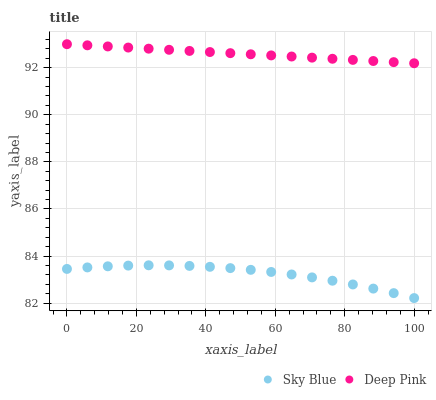Does Sky Blue have the minimum area under the curve?
Answer yes or no. Yes. Does Deep Pink have the maximum area under the curve?
Answer yes or no. Yes. Does Deep Pink have the minimum area under the curve?
Answer yes or no. No. Is Deep Pink the smoothest?
Answer yes or no. Yes. Is Sky Blue the roughest?
Answer yes or no. Yes. Is Deep Pink the roughest?
Answer yes or no. No. Does Sky Blue have the lowest value?
Answer yes or no. Yes. Does Deep Pink have the lowest value?
Answer yes or no. No. Does Deep Pink have the highest value?
Answer yes or no. Yes. Is Sky Blue less than Deep Pink?
Answer yes or no. Yes. Is Deep Pink greater than Sky Blue?
Answer yes or no. Yes. Does Sky Blue intersect Deep Pink?
Answer yes or no. No. 